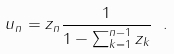Convert formula to latex. <formula><loc_0><loc_0><loc_500><loc_500>u _ { n } = z _ { n } \frac { 1 } { 1 - \sum _ { k = 1 } ^ { n - 1 } z _ { k } } \ .</formula> 